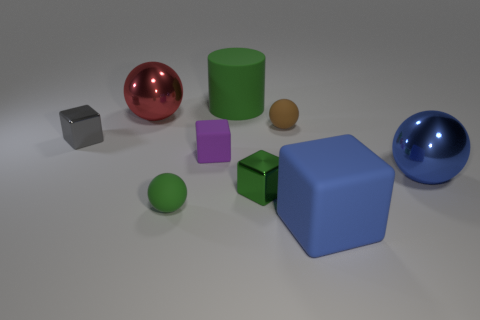Subtract all purple balls. Subtract all cyan cubes. How many balls are left? 4 Add 1 small cyan spheres. How many objects exist? 10 Subtract all cubes. How many objects are left? 5 Subtract 1 brown spheres. How many objects are left? 8 Subtract all purple objects. Subtract all big red metallic objects. How many objects are left? 7 Add 5 red metal objects. How many red metal objects are left? 6 Add 1 tiny green metallic objects. How many tiny green metallic objects exist? 2 